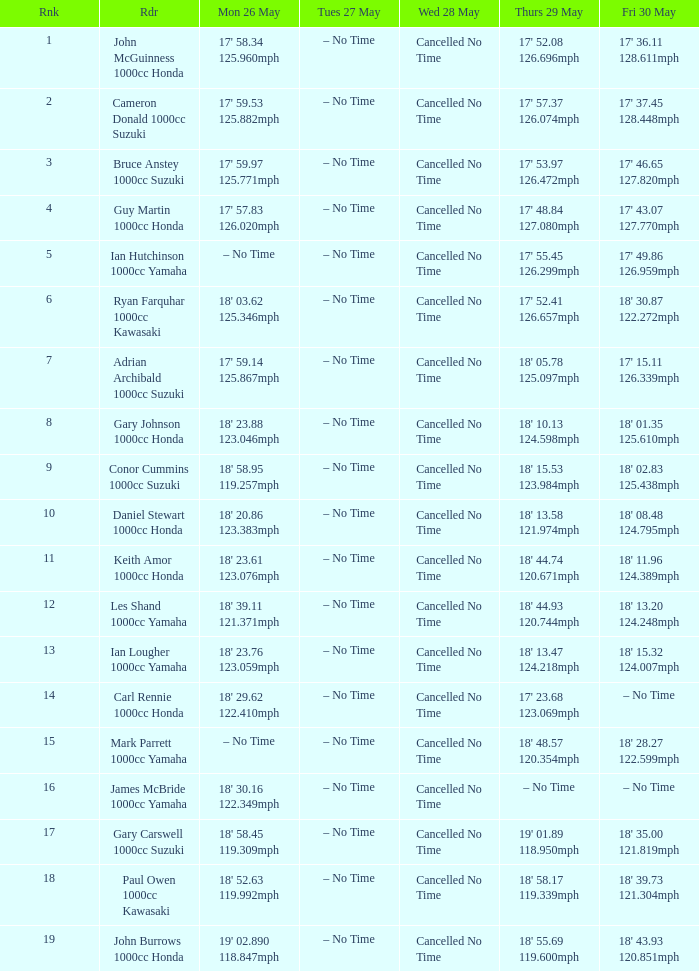When does the speed of 122.599 mph occur for a distance of 18' 28.27" on both monday, may 26 and friday, may 30? – No Time. 